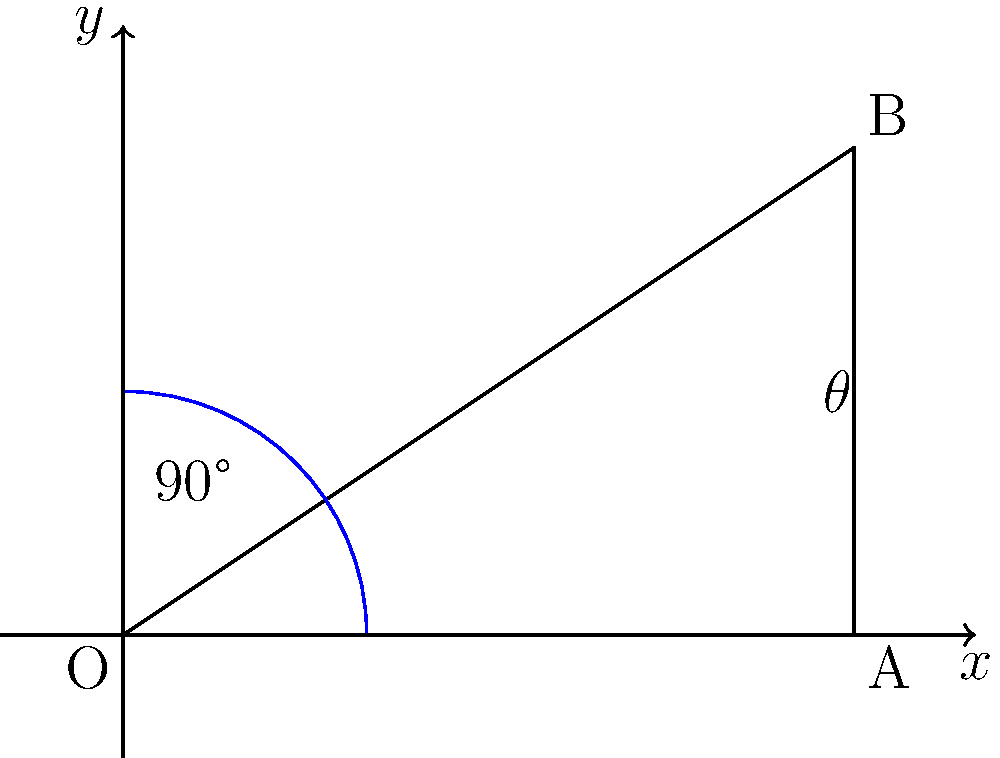A patient who recently underwent rotator cuff repair is undergoing shoulder abduction assessment. The initial position of the arm is along the x-axis (OA), and the final position after abduction is represented by OB. If OA = 3 units and OB = 3.61 units, what is the angle of shoulder abduction (θ) achieved by the patient? To solve this problem, we'll use trigonometry:

1) In the right-angled triangle OAB:
   - OA is the adjacent side to angle θ
   - AB is the opposite side to angle θ
   - OB is the hypotenuse

2) We know:
   OA = 3 units
   OB = 3.61 units

3) To find θ, we can use the cosine function:

   $$\cos(\theta) = \frac{\text{adjacent}}{\text{hypotenuse}} = \frac{OA}{OB}$$

4) Substituting the known values:

   $$\cos(\theta) = \frac{3}{3.61}$$

5) To solve for θ, we take the inverse cosine (arccos) of both sides:

   $$\theta = \arccos(\frac{3}{3.61})$$

6) Using a calculator or computer:

   $$\theta \approx 0.5699 \text{ radians}$$

7) Convert to degrees:

   $$\theta \approx 0.5699 \times \frac{180°}{\pi} \approx 32.65°$$

Therefore, the angle of shoulder abduction achieved by the patient is approximately 32.65°.
Answer: 32.65° 